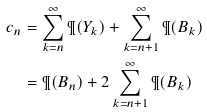<formula> <loc_0><loc_0><loc_500><loc_500>c _ { n } & = \sum _ { k = n } ^ { \infty } \P ( Y _ { k } ) + \sum _ { k = n + 1 } ^ { \infty } \P ( B _ { k } ) \\ & = \P ( B _ { n } ) + 2 \sum _ { k = n + 1 } ^ { \infty } \P ( B _ { k } )</formula> 